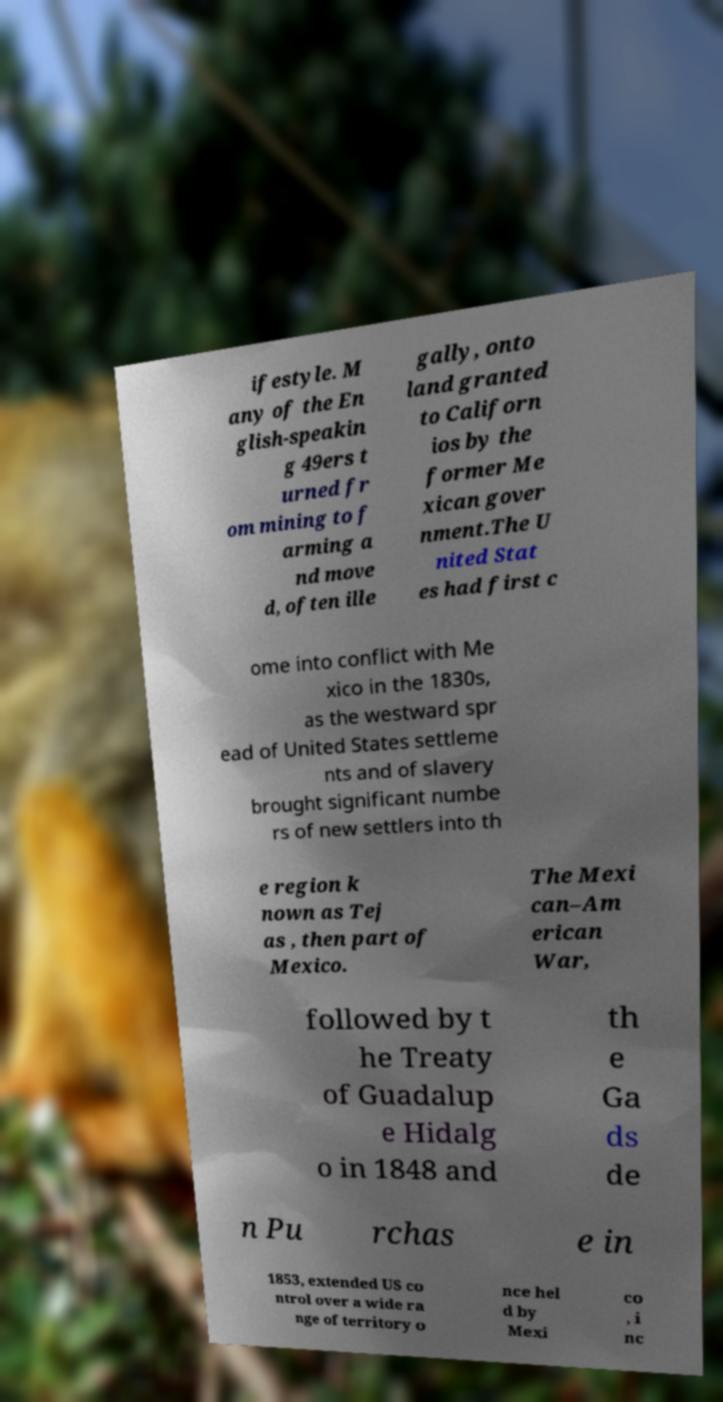There's text embedded in this image that I need extracted. Can you transcribe it verbatim? ifestyle. M any of the En glish-speakin g 49ers t urned fr om mining to f arming a nd move d, often ille gally, onto land granted to Californ ios by the former Me xican gover nment.The U nited Stat es had first c ome into conflict with Me xico in the 1830s, as the westward spr ead of United States settleme nts and of slavery brought significant numbe rs of new settlers into th e region k nown as Tej as , then part of Mexico. The Mexi can–Am erican War, followed by t he Treaty of Guadalup e Hidalg o in 1848 and th e Ga ds de n Pu rchas e in 1853, extended US co ntrol over a wide ra nge of territory o nce hel d by Mexi co , i nc 